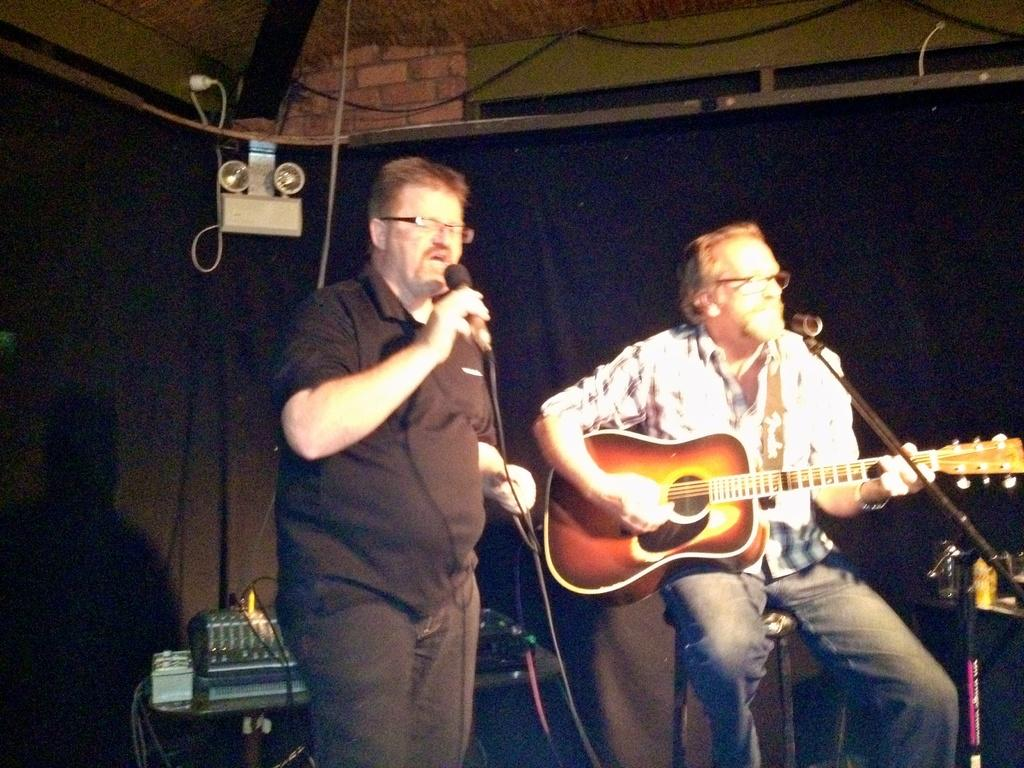How many people are in the image? There are two persons in the image. What is the man on the left side holding? The man on the left side is holding a microphone in his hand. What is the man on the left side doing? The man on the left side is singing. What is the man on the right side holding? The man on the right side is holding a guitar. What is the man on the right side doing? The man on the right side is singing. What type of thunder can be heard in the background of the image? There is no thunder present in the image; it is a picture of two men singing with a microphone and a guitar. 